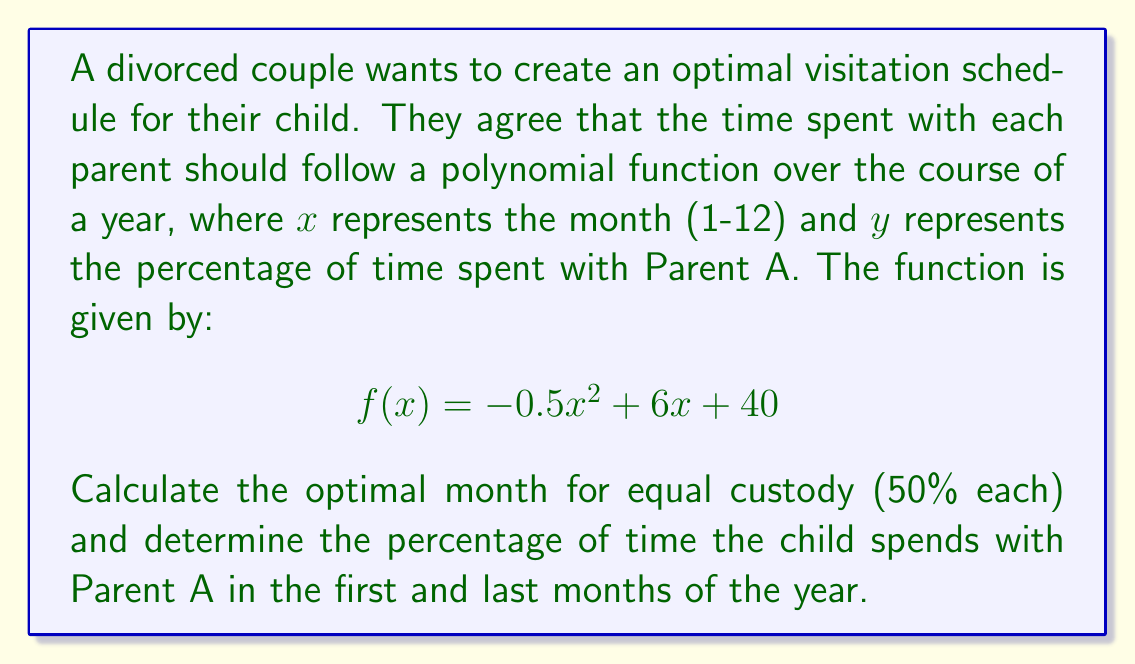Can you answer this question? 1. To find the month of equal custody, we need to solve the equation:
   $$f(x) = 50$$
   $$-0.5x^2 + 6x + 40 = 50$$
   $$-0.5x^2 + 6x - 10 = 0$$

2. This is a quadratic equation. We can solve it using the quadratic formula:
   $$x = \frac{-b \pm \sqrt{b^2 - 4ac}}{2a}$$
   Where $a = -0.5$, $b = 6$, and $c = -10$

3. Substituting these values:
   $$x = \frac{-6 \pm \sqrt{6^2 - 4(-0.5)(-10)}}{2(-0.5)}$$
   $$x = \frac{-6 \pm \sqrt{36 - 20}}{-1}$$
   $$x = \frac{-6 \pm \sqrt{16}}{-1}$$
   $$x = \frac{-6 \pm 4}{-1}$$

4. This gives us two solutions:
   $$x_1 = \frac{-6 + 4}{-1} = 2$$
   $$x_2 = \frac{-6 - 4}{-1} = 10$$

5. Since we're dealing with months, the solution $x = 2$ (February) is the optimal month for equal custody.

6. For the first month (January, $x = 1$):
   $$f(1) = -0.5(1)^2 + 6(1) + 40 = -0.5 + 6 + 40 = 45.5\%$$

7. For the last month (December, $x = 12$):
   $$f(12) = -0.5(12)^2 + 6(12) + 40 = -72 + 72 + 40 = 40\%$$
Answer: Equal custody: Month 2 (February); January: 45.5% with Parent A; December: 40% with Parent A 